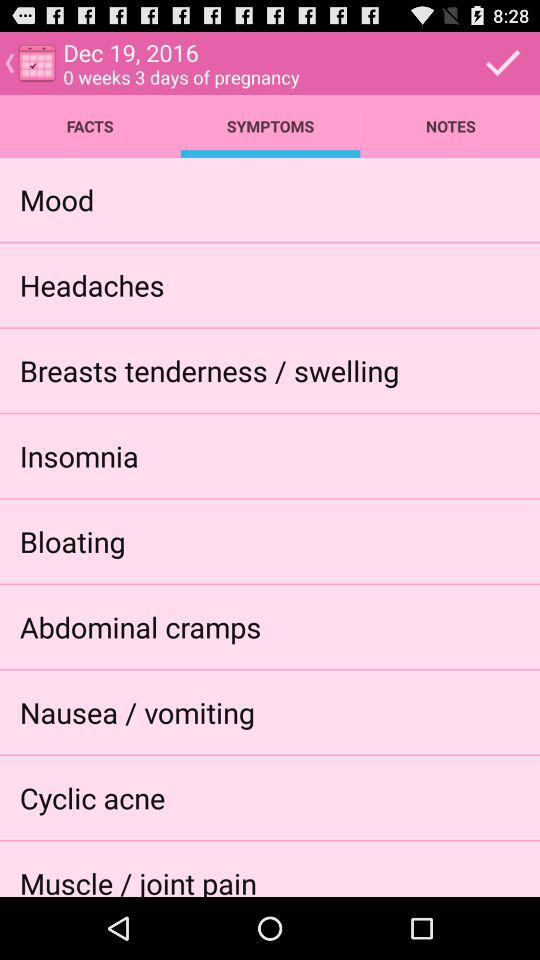Which tab am I using? You are using "SYMPTOMS" tab. 